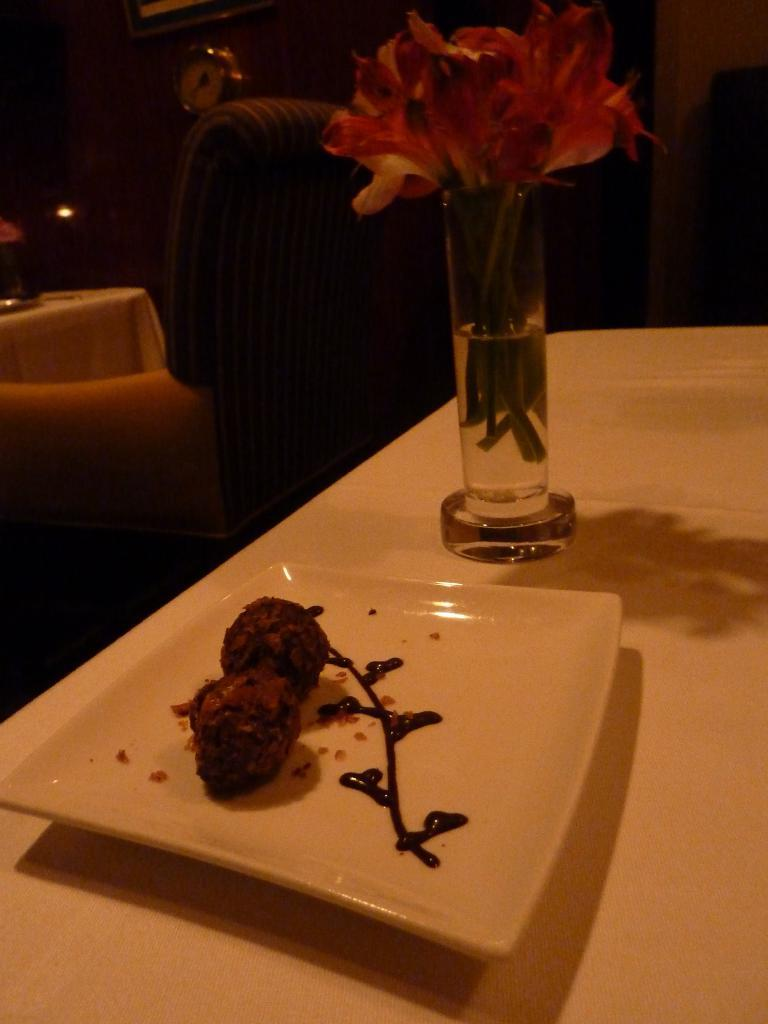What is on the plate that is visible in the image? There is a plate filled with food items in the image. What else can be seen in the image besides the plate of food? There is a flower glass in the image. What is the flower glass placed on? The flower glass is placed on a wooden surface. What type of truck is parked next to the wooden surface in the image? There is no truck present in the image; it only features a plate of food and a flower glass on a wooden surface. 